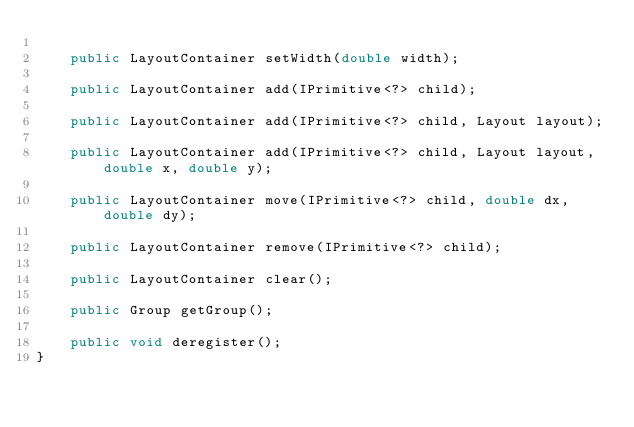<code> <loc_0><loc_0><loc_500><loc_500><_Java_>
    public LayoutContainer setWidth(double width);

    public LayoutContainer add(IPrimitive<?> child);

    public LayoutContainer add(IPrimitive<?> child, Layout layout);

    public LayoutContainer add(IPrimitive<?> child, Layout layout, double x, double y);

    public LayoutContainer move(IPrimitive<?> child, double dx, double dy);

    public LayoutContainer remove(IPrimitive<?> child);

    public LayoutContainer clear();

    public Group getGroup();

    public void deregister();
}
</code> 